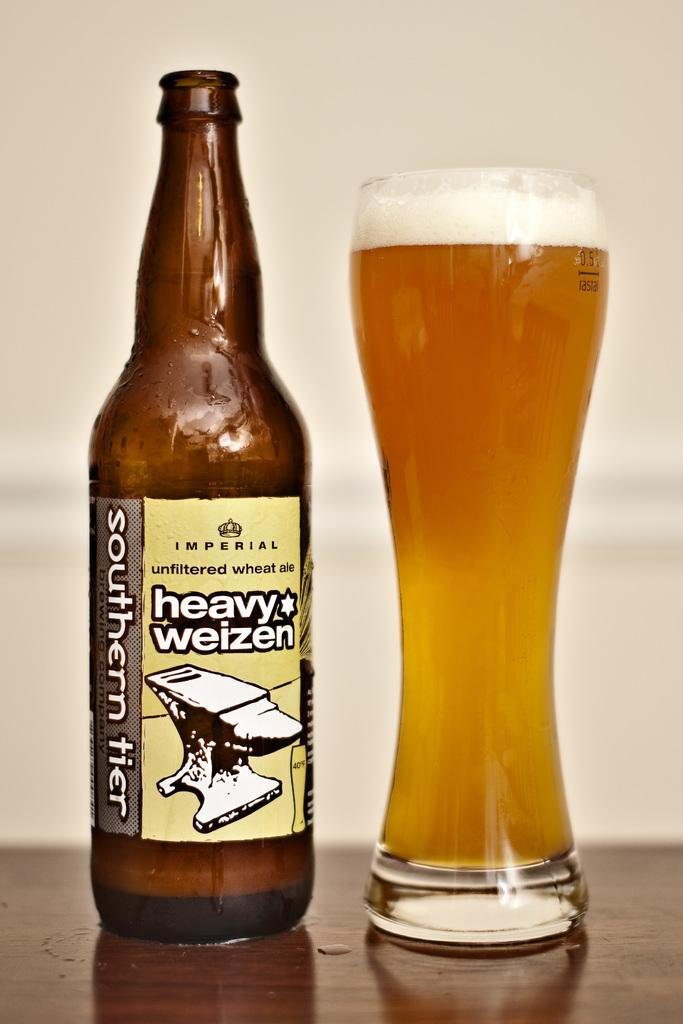<image>
Provide a brief description of the given image. The pint shown contains heavy weizen beer from the bottle beside it. 